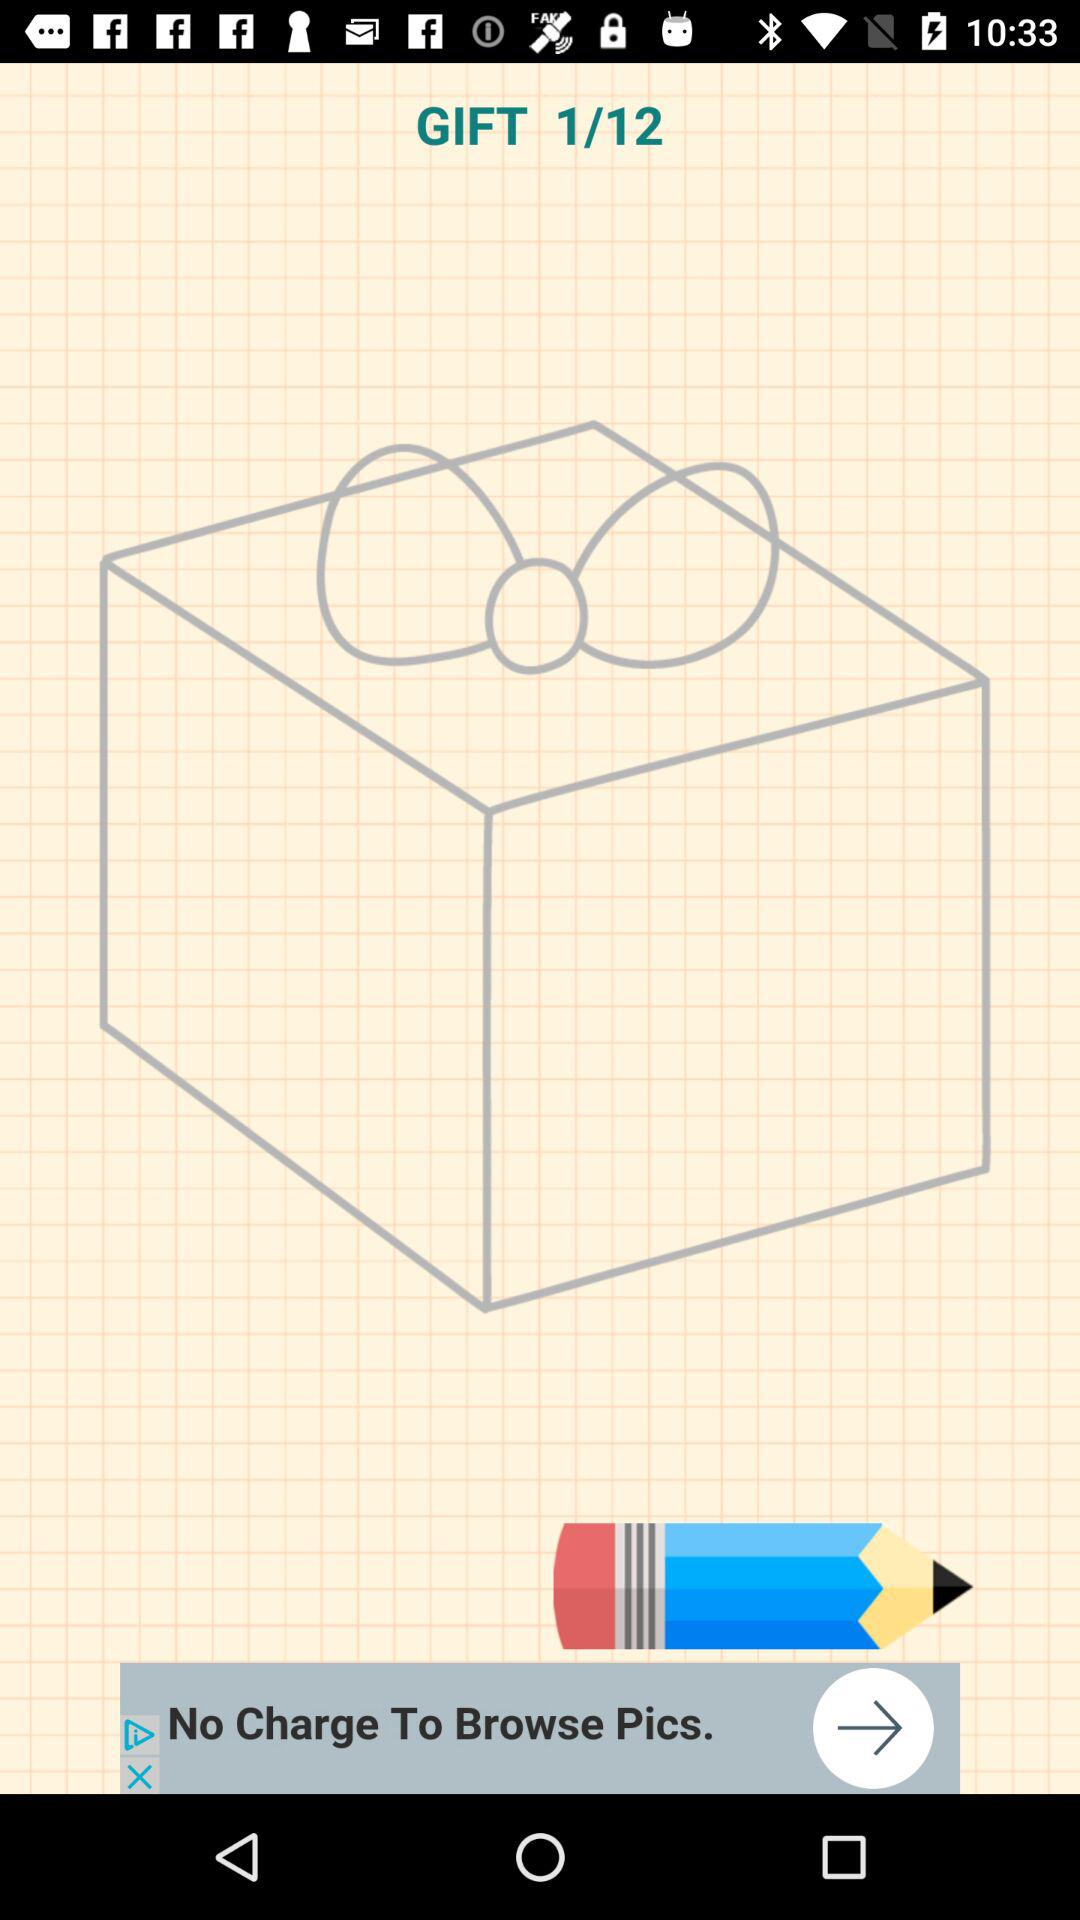How many steps in total are there? There are 12 steps in total. 